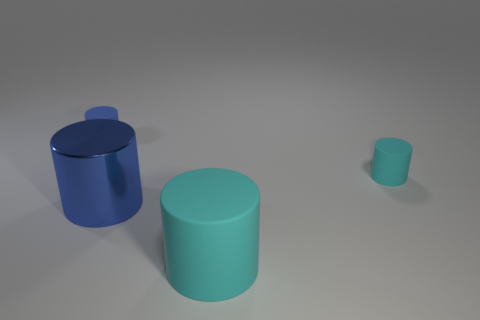What shape is the big thing in front of the big blue metal thing?
Make the answer very short. Cylinder. Is the material of the big cyan cylinder the same as the small cyan cylinder?
Your answer should be compact. Yes. What number of small cylinders are behind the small cyan thing?
Provide a short and direct response. 1. Is the number of cyan rubber cylinders behind the big cyan cylinder greater than the number of yellow metallic blocks?
Your answer should be compact. Yes. How many small matte objects are in front of the cyan rubber cylinder in front of the tiny cyan rubber cylinder?
Offer a very short reply. 0. The object in front of the blue cylinder in front of the small matte thing right of the metallic cylinder is what shape?
Your response must be concise. Cylinder. The blue matte thing has what size?
Offer a very short reply. Small. Are there any cyan cylinders made of the same material as the big cyan object?
Your answer should be very brief. Yes. The metallic thing that is the same shape as the tiny cyan rubber thing is what size?
Make the answer very short. Large. Is the number of large shiny cylinders behind the tiny cyan rubber cylinder the same as the number of brown matte objects?
Provide a succinct answer. Yes. 